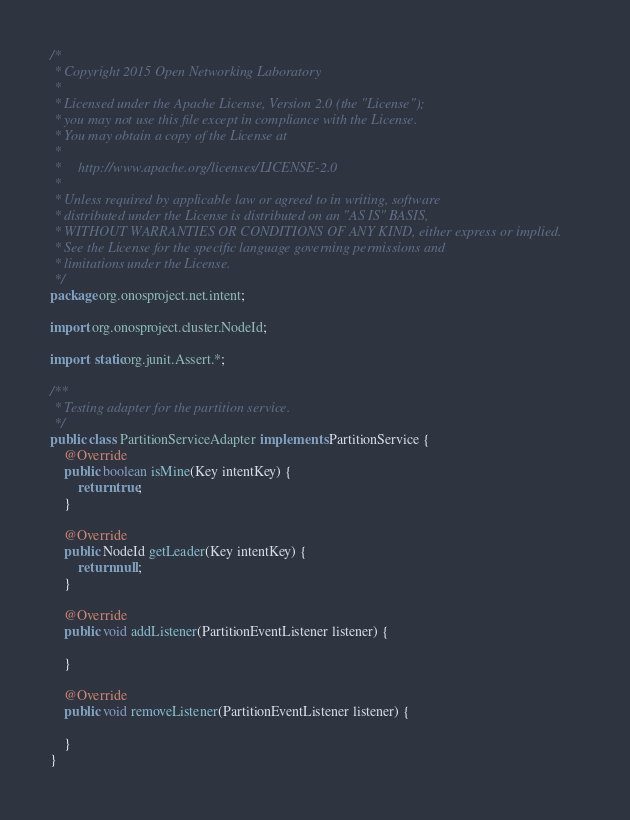<code> <loc_0><loc_0><loc_500><loc_500><_Java_>/*
 * Copyright 2015 Open Networking Laboratory
 *
 * Licensed under the Apache License, Version 2.0 (the "License");
 * you may not use this file except in compliance with the License.
 * You may obtain a copy of the License at
 *
 *     http://www.apache.org/licenses/LICENSE-2.0
 *
 * Unless required by applicable law or agreed to in writing, software
 * distributed under the License is distributed on an "AS IS" BASIS,
 * WITHOUT WARRANTIES OR CONDITIONS OF ANY KIND, either express or implied.
 * See the License for the specific language governing permissions and
 * limitations under the License.
 */
package org.onosproject.net.intent;

import org.onosproject.cluster.NodeId;

import static org.junit.Assert.*;

/**
 * Testing adapter for the partition service.
 */
public class PartitionServiceAdapter implements PartitionService {
    @Override
    public boolean isMine(Key intentKey) {
        return true;
    }

    @Override
    public NodeId getLeader(Key intentKey) {
        return null;
    }

    @Override
    public void addListener(PartitionEventListener listener) {

    }

    @Override
    public void removeListener(PartitionEventListener listener) {

    }
}
</code> 